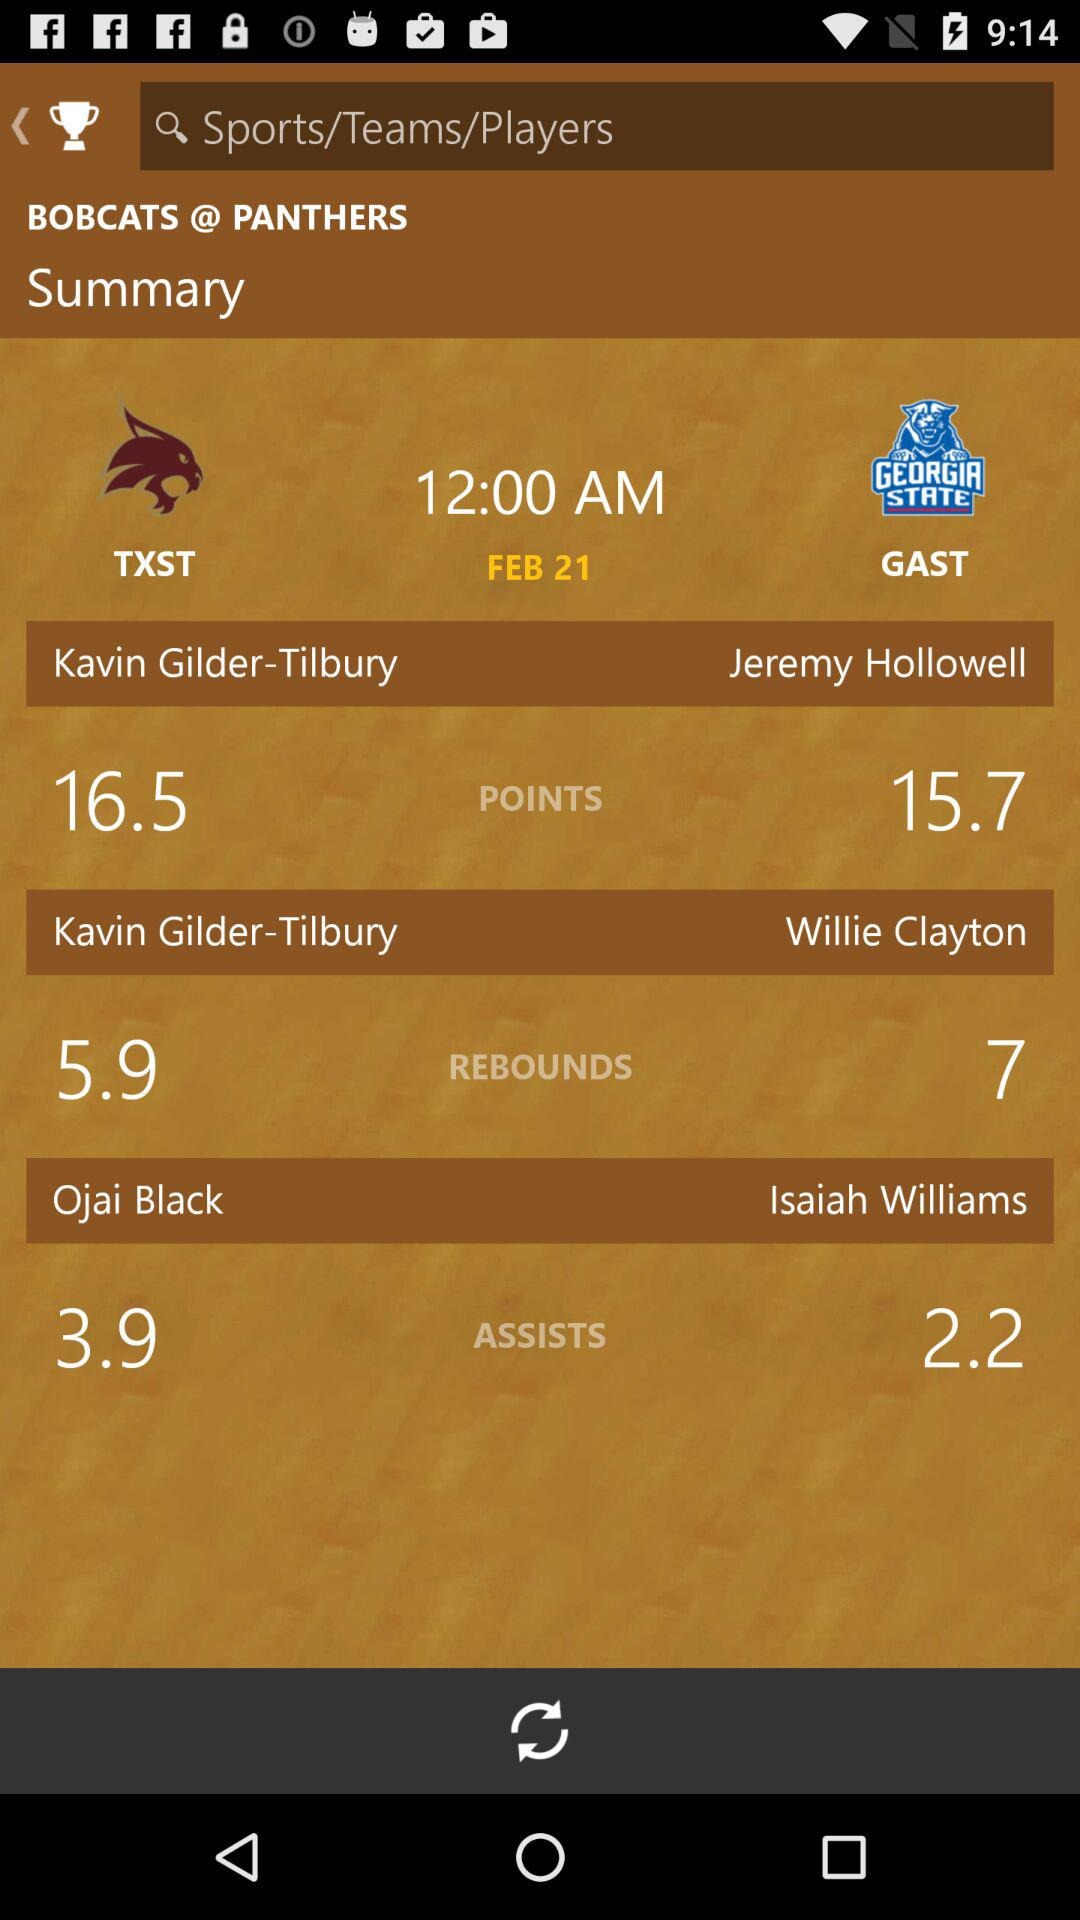Willie Clayton has how many rebounds? Willie Clayton has 7 rebounds. 